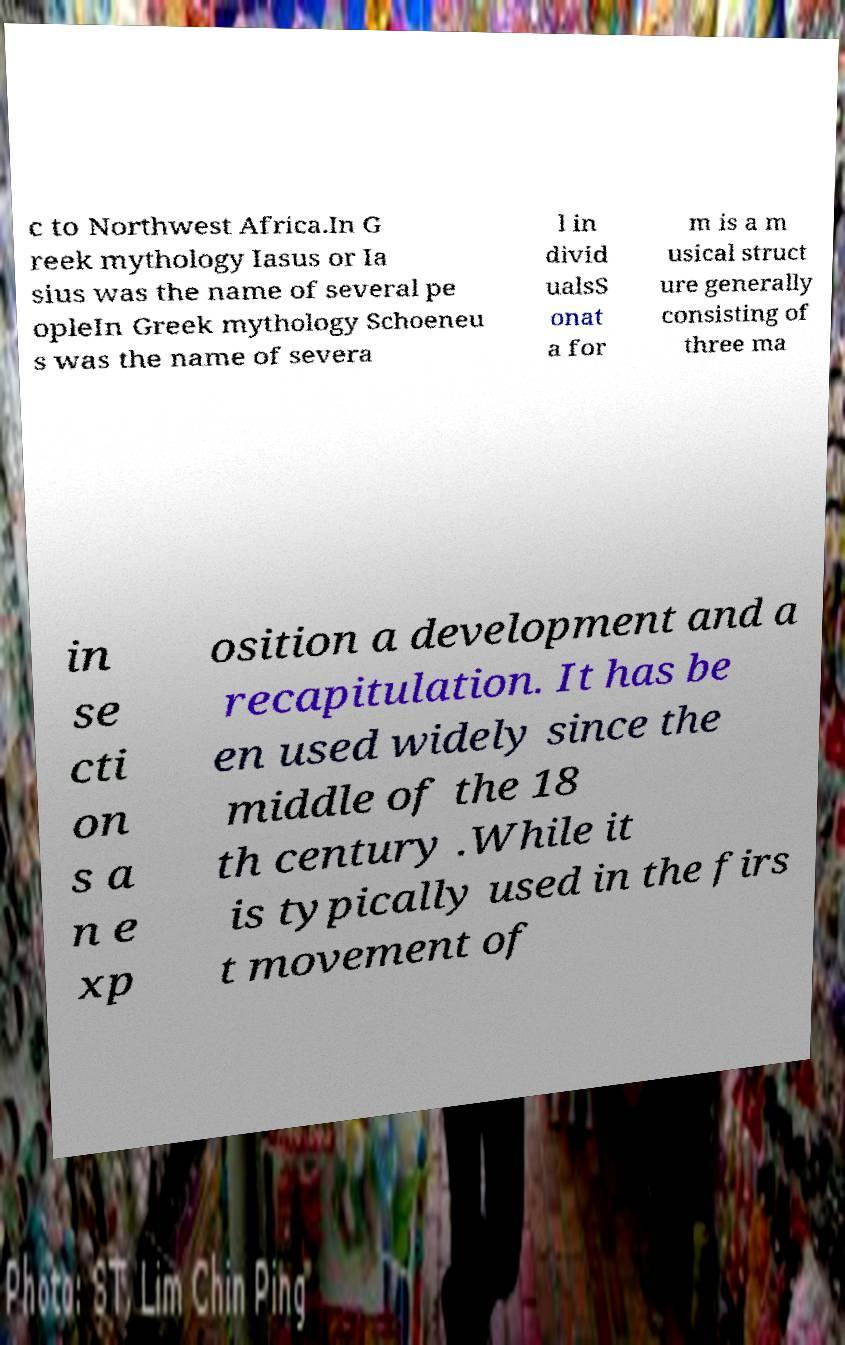Please read and relay the text visible in this image. What does it say? c to Northwest Africa.In G reek mythology Iasus or Ia sius was the name of several pe opleIn Greek mythology Schoeneu s was the name of severa l in divid ualsS onat a for m is a m usical struct ure generally consisting of three ma in se cti on s a n e xp osition a development and a recapitulation. It has be en used widely since the middle of the 18 th century .While it is typically used in the firs t movement of 